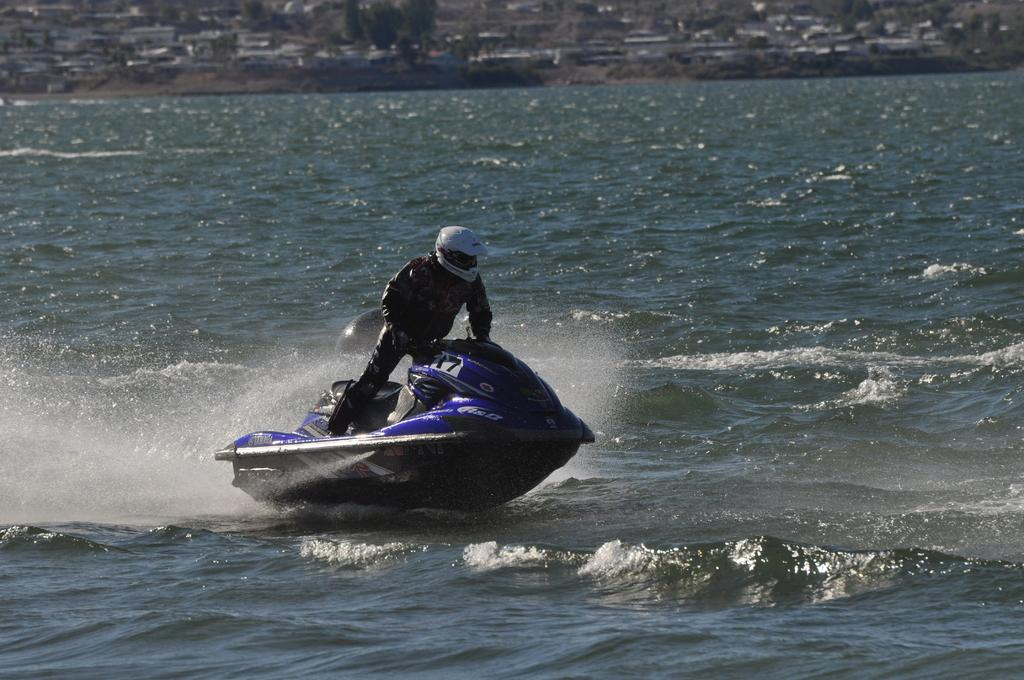Who is present in the image? There is a man in the image. What is the man wearing on his head? The man is wearing a helmet. What activity is the man engaged in? The man is boating on the surface of the water. What can be seen in the background of the image? There are trees and buildings in the background of the image. What type of milk is being spilled from the train in the image? There is no train or milk present in the image; it features a man boating on the water with trees and buildings in the background. 